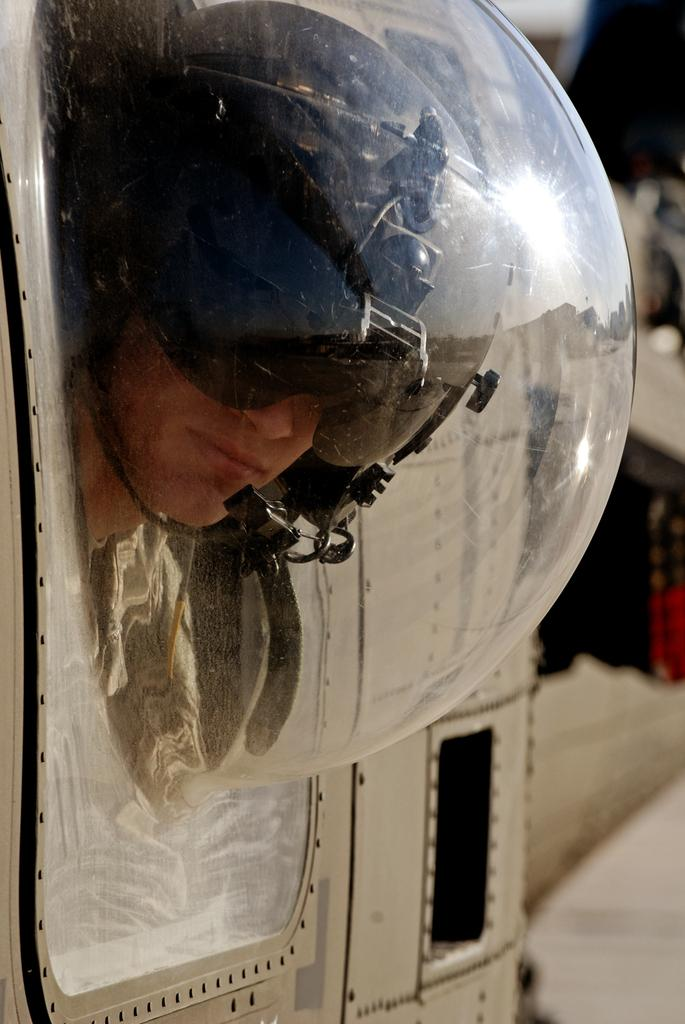Who is the main subject in the foreground of the image? There is a man in the foreground of the image. What is the man wearing on his head? The man is wearing a helmet. What is the man looking through in the image? The man is looking through a globe-like glass window. What type of vehicle is the man in? The window is part of a vehicle. How many fish can be seen swimming in the vehicle's window in the image? There are no fish visible in the vehicle's window in the image. What type of parcel is the man holding in the image? The man is not holding any parcel in the image. 